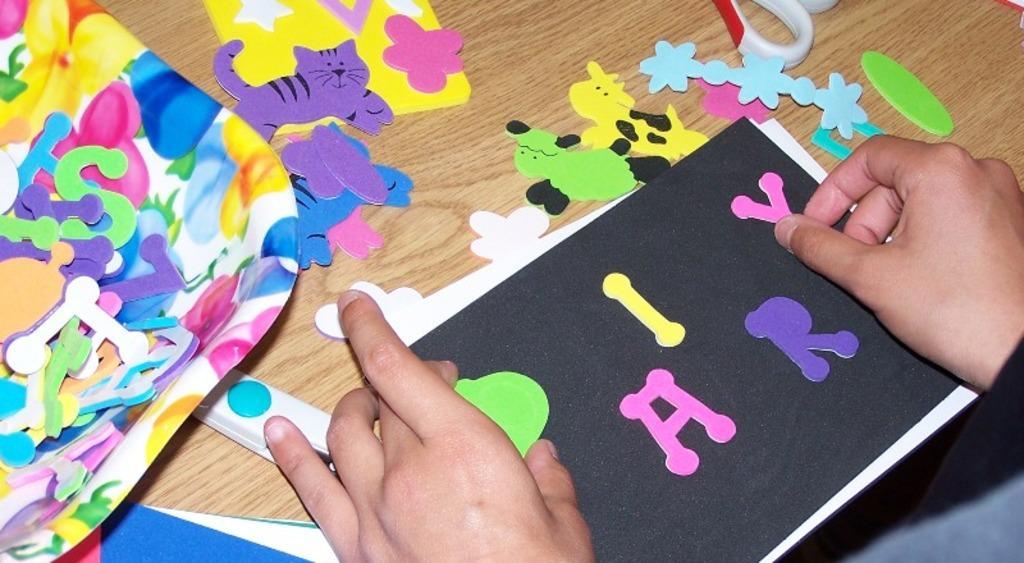Please provide a concise description of this image. In this image we can see paper toys on the wooden surface. There are person's hand. 